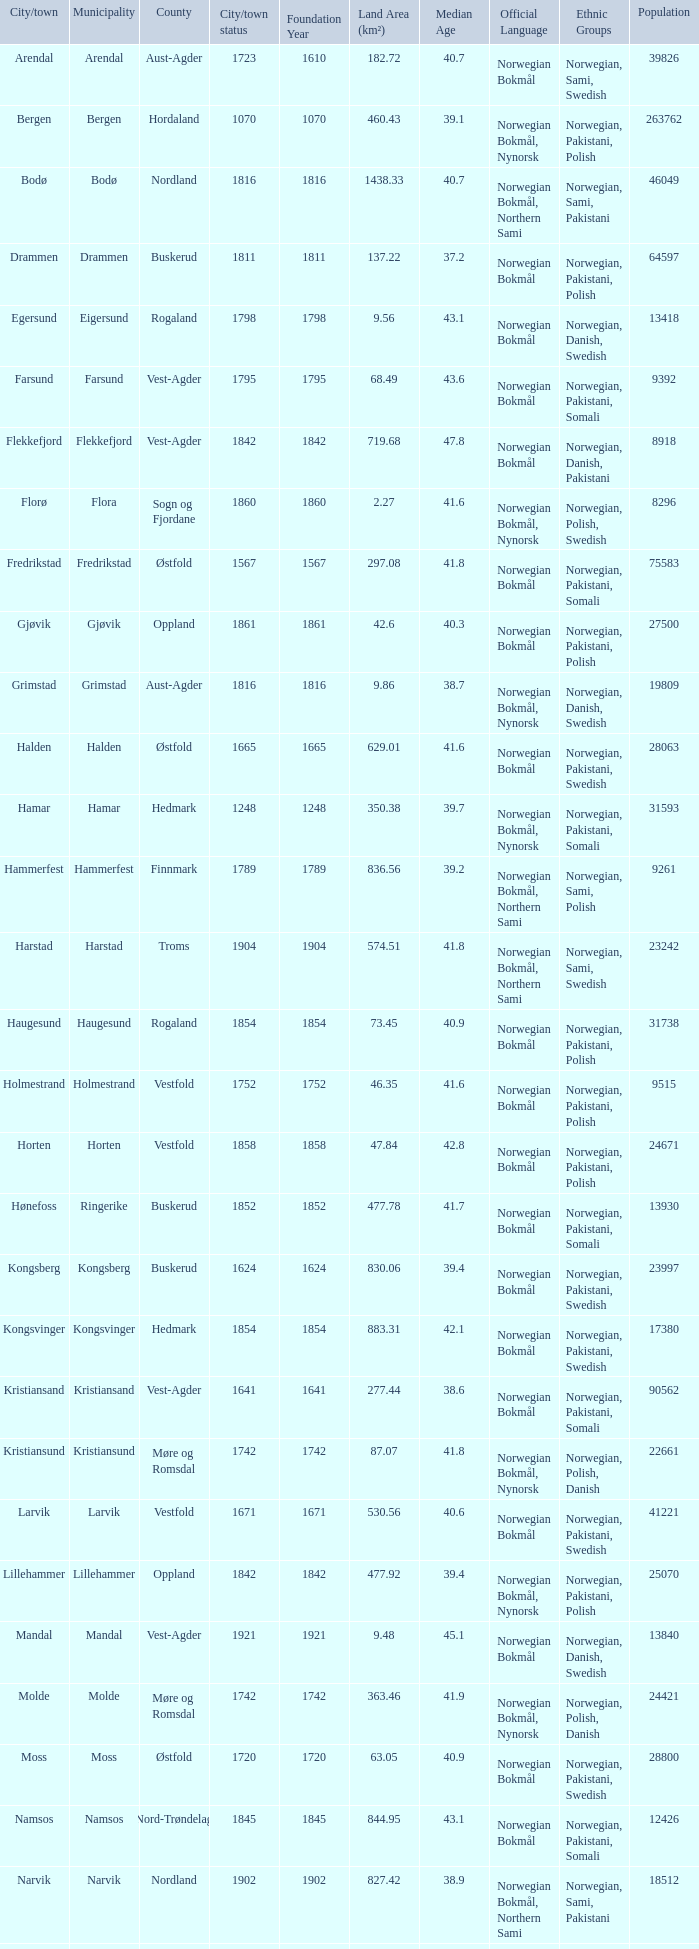What are the cities/towns located in the municipality of Horten? Horten. 